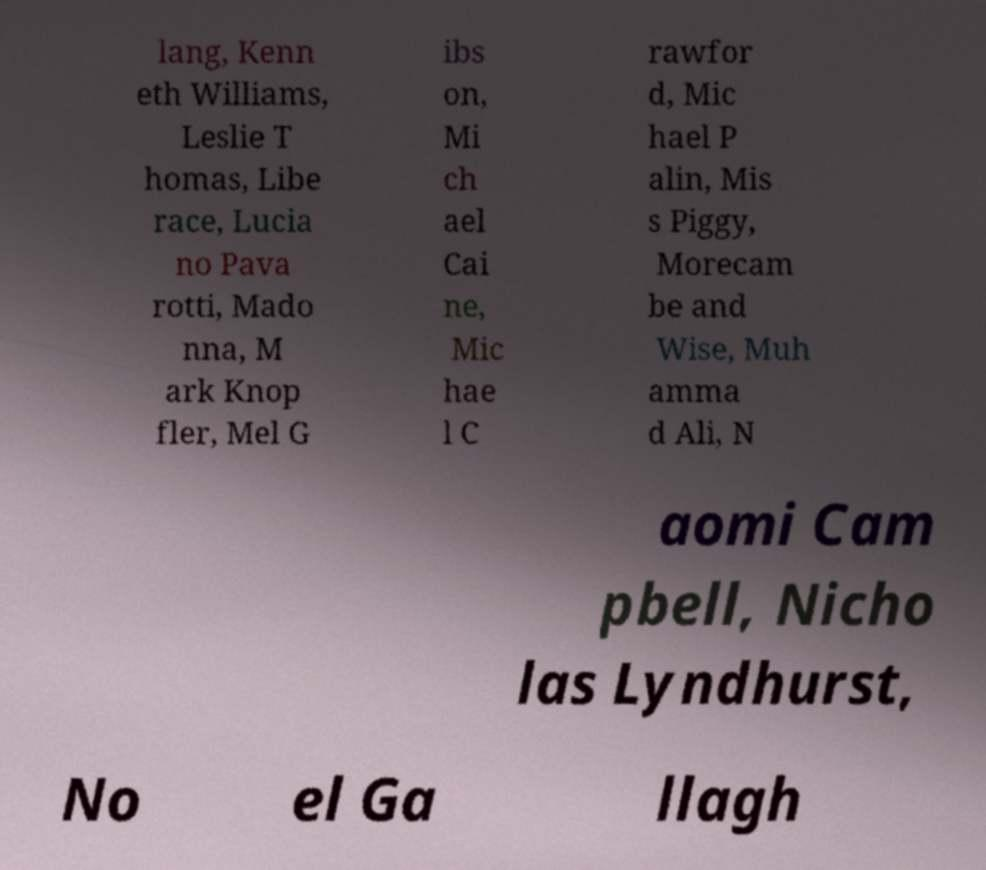Could you assist in decoding the text presented in this image and type it out clearly? lang, Kenn eth Williams, Leslie T homas, Libe race, Lucia no Pava rotti, Mado nna, M ark Knop fler, Mel G ibs on, Mi ch ael Cai ne, Mic hae l C rawfor d, Mic hael P alin, Mis s Piggy, Morecam be and Wise, Muh amma d Ali, N aomi Cam pbell, Nicho las Lyndhurst, No el Ga llagh 